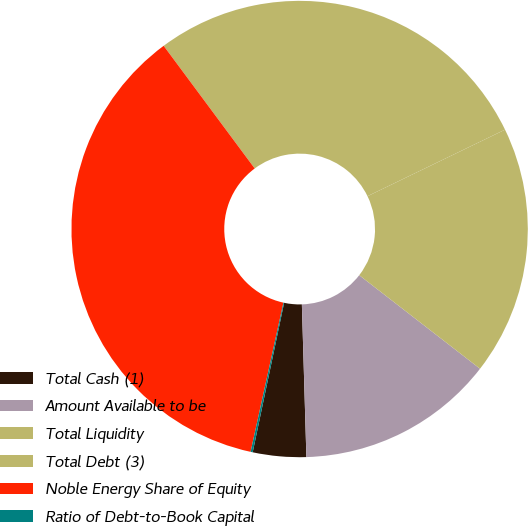<chart> <loc_0><loc_0><loc_500><loc_500><pie_chart><fcel>Total Cash (1)<fcel>Amount Available to be<fcel>Total Liquidity<fcel>Total Debt (3)<fcel>Noble Energy Share of Equity<fcel>Ratio of Debt-to-Book Capital<nl><fcel>3.77%<fcel>14.04%<fcel>17.66%<fcel>27.99%<fcel>36.39%<fcel>0.15%<nl></chart> 